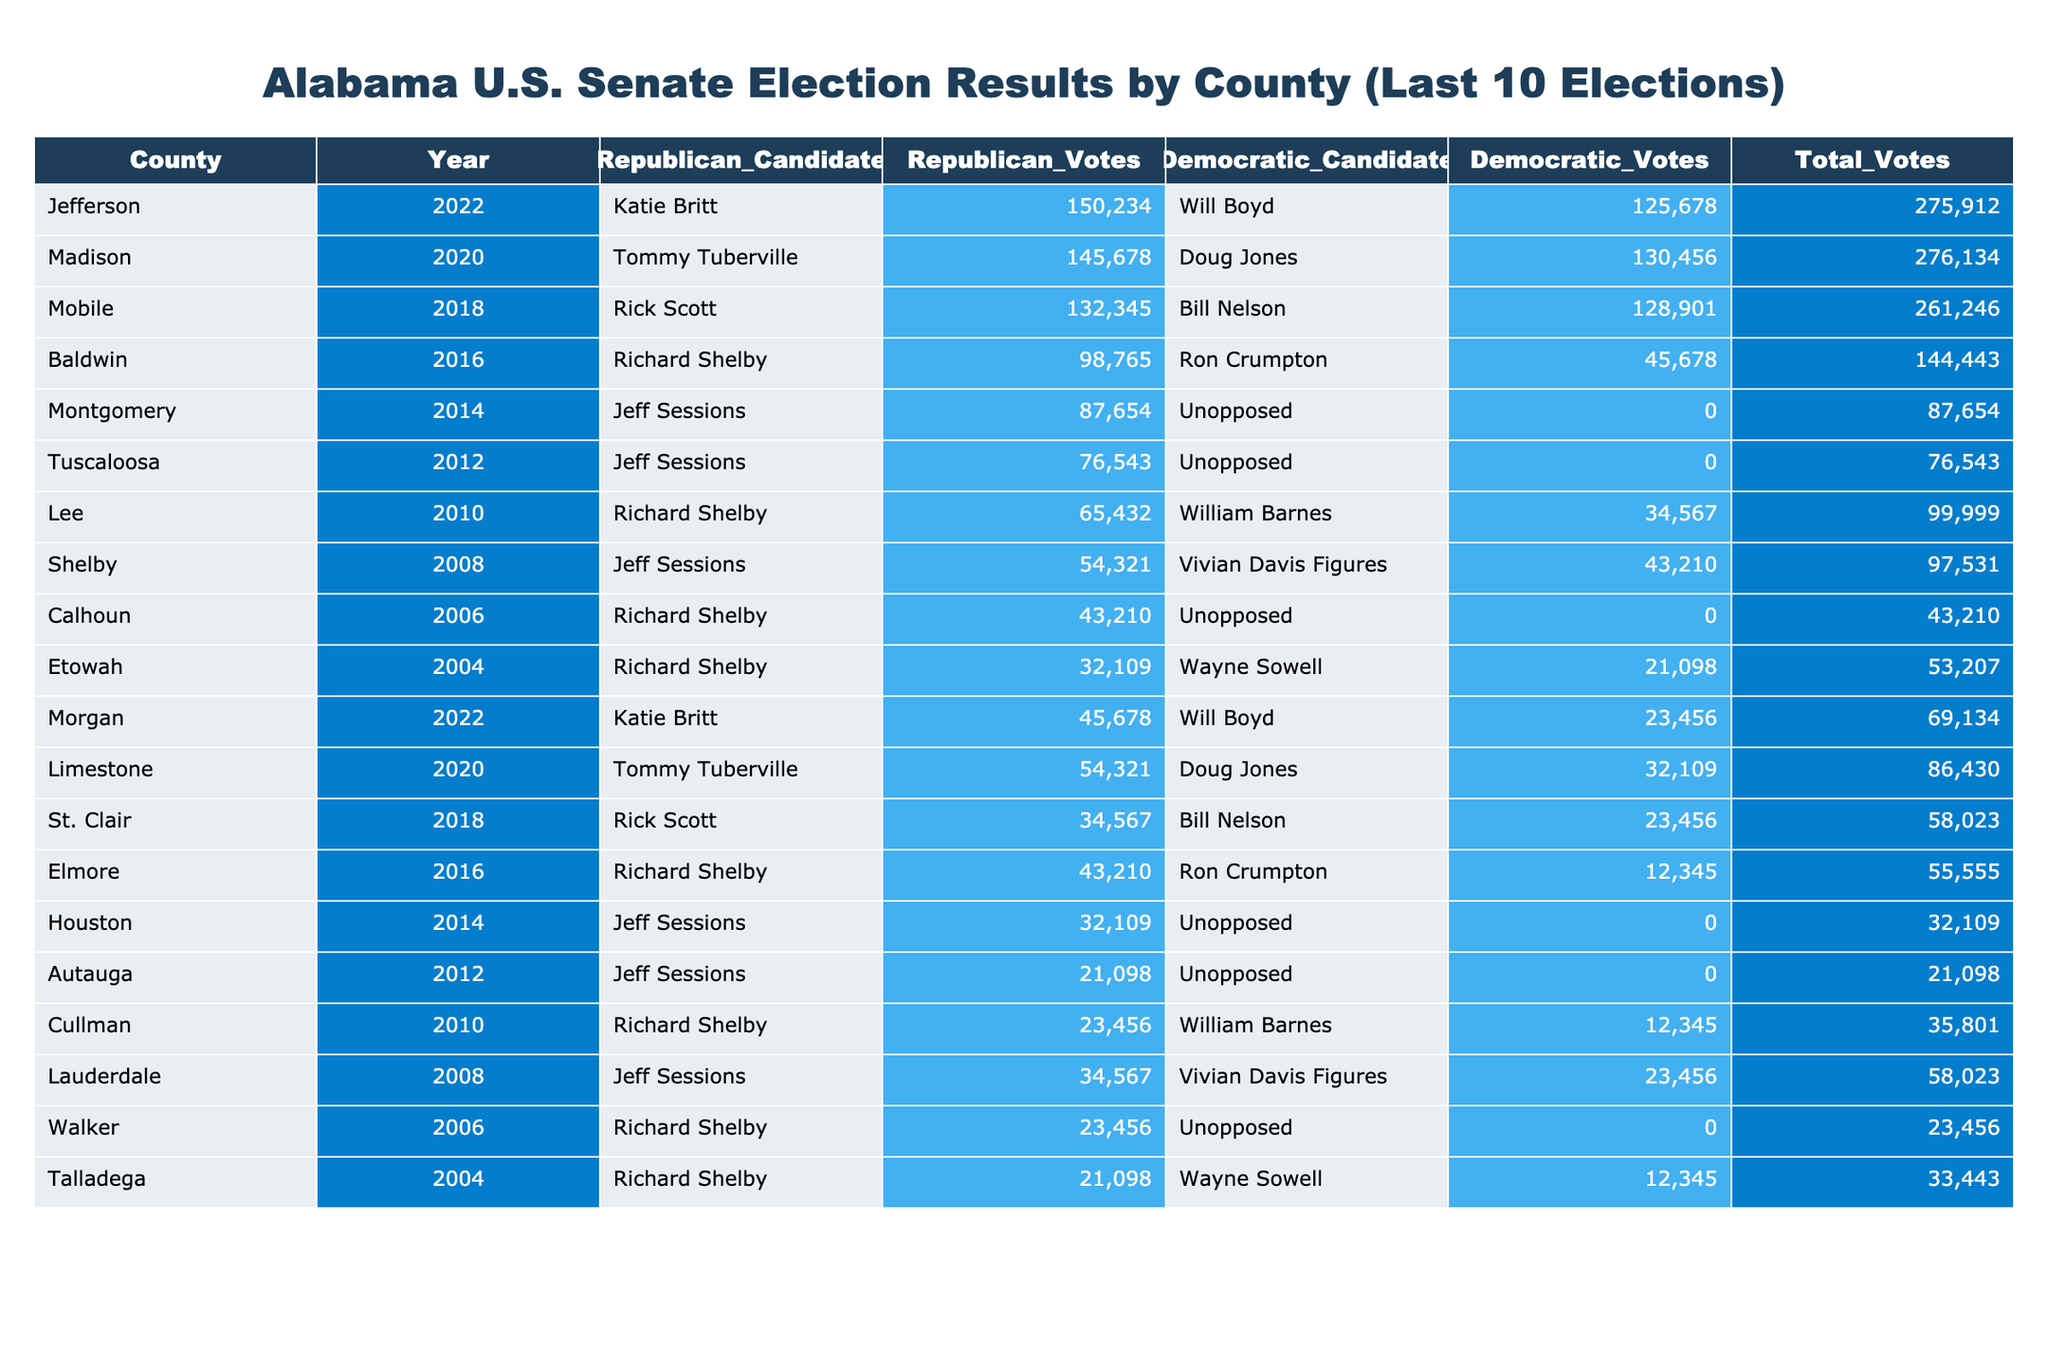What county had the highest total votes in the 2022 Senate election? Referring to the table, in the 2022 election for Jefferson County, the total votes were 275912, which is the highest total when compared to other counties for that year.
Answer: Jefferson What was the total number of votes in the 2018 Senate election? By looking at the total votes of each county for the 2018 election, we can sum them: Mobile (261246) + St. Clair (58023) = 319269 total votes in 2018.
Answer: 319269 Which candidate won in Montgomery in 2014? In Montgomery County for the 2014 election, there was only a Republican candidate, Jeff Sessions, who received 87654 votes, meaning he was the only candidate and thus won by default.
Answer: Jeff Sessions What was the difference in Republican votes between 2022 and 2020 for Madison County? For Madison County in 2022, the Republican votes were 145678, and in 2020, they were 54321. The difference is calculated as 145678 - 54321, which equals 91357.
Answer: 91357 Did any county have an unopposed Democratic candidate from 2004 to 2022? Upon reviewing the data, the table shows that only Montgomery in 2014 had an unopposed Democratic candidate. Therefore, the answer is yes.
Answer: Yes What is the average number of Republican votes across all the elections listed in the table? To determine this, we first sum the Republican votes: 150234 + 145678 + 132345 + 98765 + 87654 + 76543 + 65432 + 54321 + 43210 + 32109 = 1091091. Then, we divide by the number of elections, which is 10. The average is 109109.1, rounded down to 109109.
Answer: 109109 Which county had the lowest Democratic votes in the 2006 election? From the 2006 data, we see that the only Democratic candidate in Calhoun County received 0 votes since they were unopposed. This indicates that Calhoun had the lowest Democratic votes.
Answer: Calhoun In how many elections did Richard Shelby run as a Republican candidate? By counting the occurrences of Richard Shelby running as a Republican in the years mentioned: 2010, 2012, 2014, 2016, and 2006 (total of 5 times).
Answer: 5 What was the total count of votes in Elmore County for the 2016 election? Checking the Elmore County entry for the 2016 election, we find 55555 as the total number of votes.
Answer: 55555 In which year did Doug Jones receive the most votes against a Republican candidate? The table indicates that Doug Jones received 130456 votes in 2020 against Tommy Tuberville, which is the highest compared to his other election years.
Answer: 2020 Which candidate received the fewest Republican votes in the 2010 election? Looking at the Republican votes in the 2010 election, Richard Shelby received 65432 votes, while William Barnes received only 12345 in Cullman. Thus, William Barnes received the fewest Republican votes.
Answer: William Barnes 